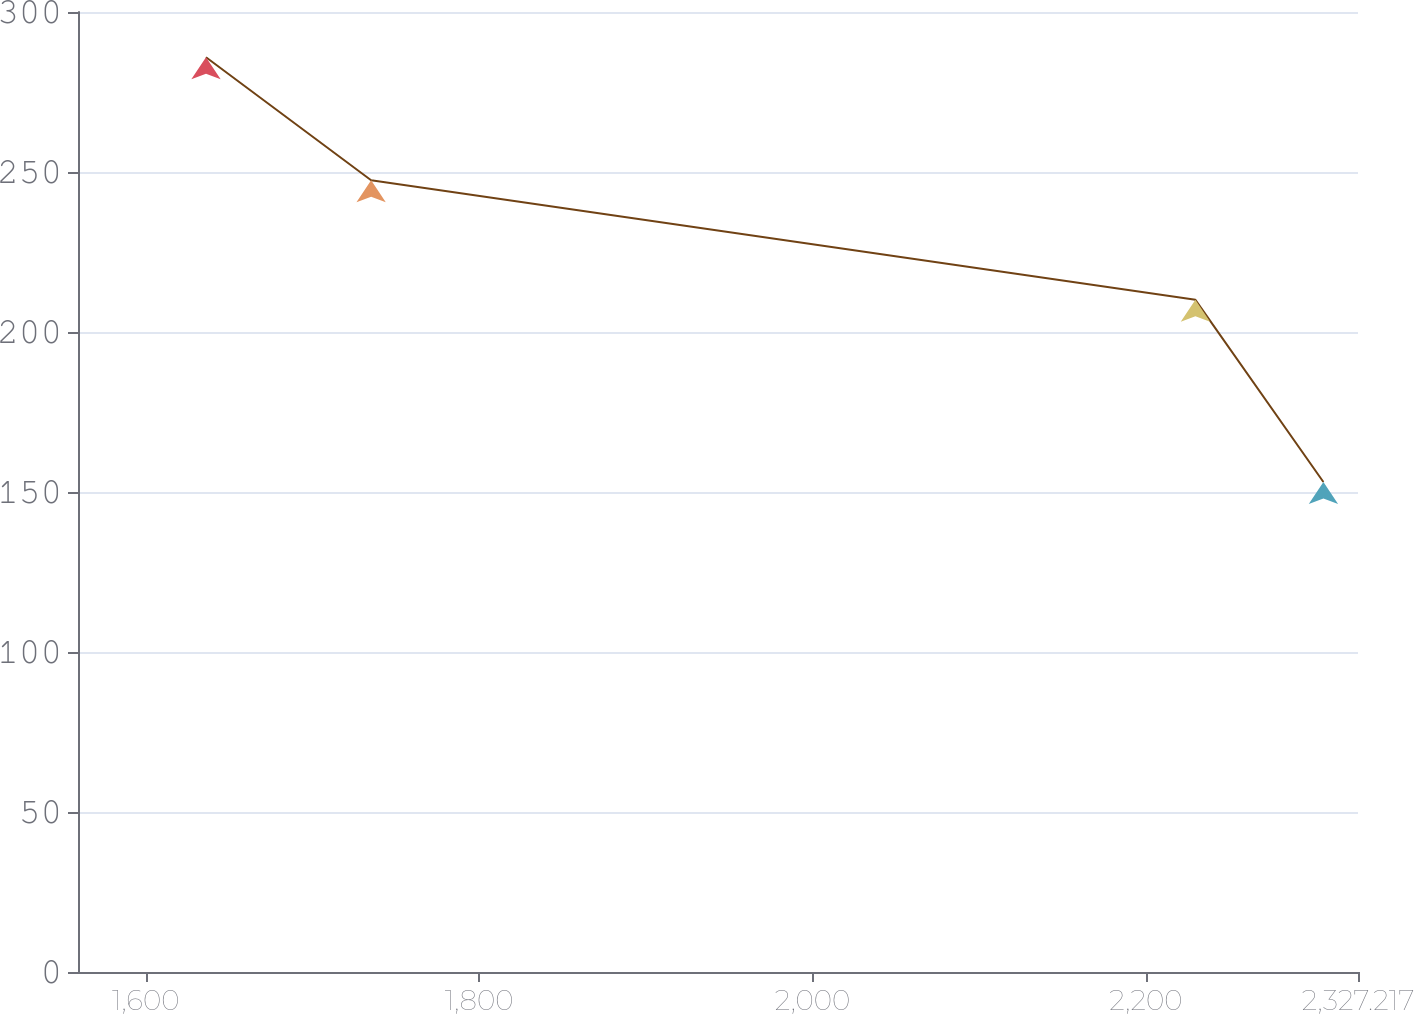<chart> <loc_0><loc_0><loc_500><loc_500><line_chart><ecel><fcel>Unnamed: 1<nl><fcel>1636.17<fcel>285.86<nl><fcel>1735.23<fcel>247.43<nl><fcel>2229.69<fcel>210.05<nl><fcel>2306.47<fcel>153.11<nl><fcel>2404<fcel>166.39<nl></chart> 